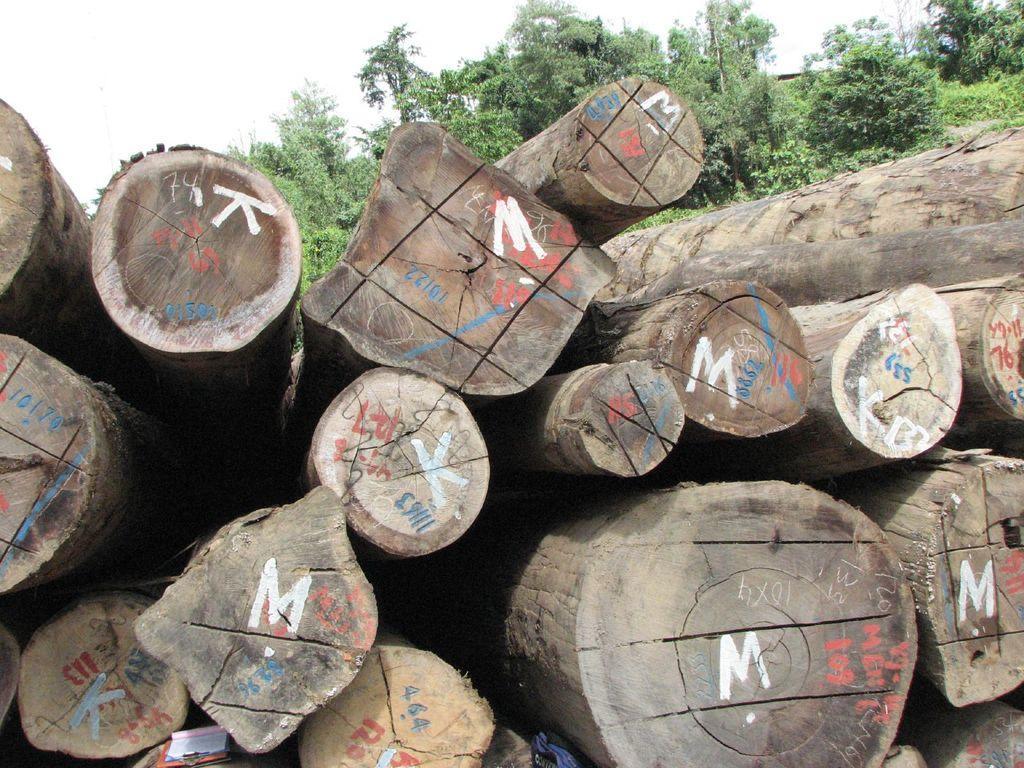Describe this image in one or two sentences. In this image we can see log. Behind the log trees are there and sky is present. 